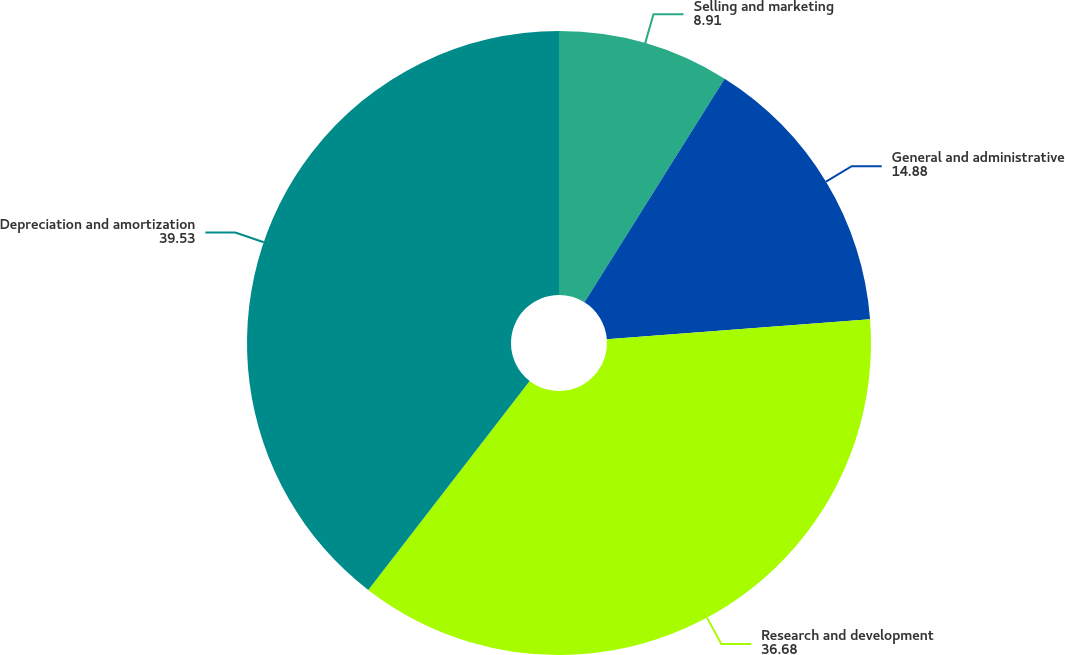Convert chart to OTSL. <chart><loc_0><loc_0><loc_500><loc_500><pie_chart><fcel>Selling and marketing<fcel>General and administrative<fcel>Research and development<fcel>Depreciation and amortization<nl><fcel>8.91%<fcel>14.88%<fcel>36.68%<fcel>39.53%<nl></chart> 